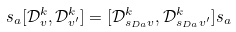Convert formula to latex. <formula><loc_0><loc_0><loc_500><loc_500>s _ { a } [ \mathcal { D } _ { v } ^ { k } , \mathcal { D } _ { v ^ { \prime } } ^ { k } ] = [ \mathcal { D } _ { s _ { D a } v } ^ { k } , \mathcal { D } _ { s _ { D a } v ^ { \prime } } ^ { k } ] s _ { a }</formula> 